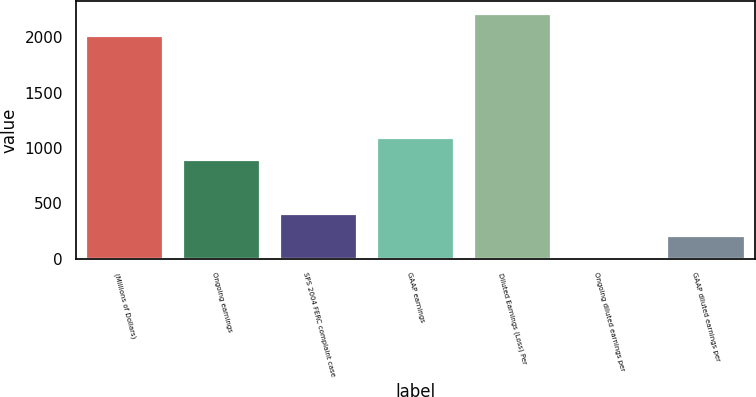Convert chart. <chart><loc_0><loc_0><loc_500><loc_500><bar_chart><fcel>(Millions of Dollars)<fcel>Ongoing earnings<fcel>SPS 2004 FERC complaint case<fcel>GAAP earnings<fcel>Diluted Earnings (Loss) Per<fcel>Ongoing diluted earnings per<fcel>GAAP diluted earnings per<nl><fcel>2012<fcel>888.3<fcel>403.86<fcel>1089.32<fcel>2213.02<fcel>1.82<fcel>202.84<nl></chart> 